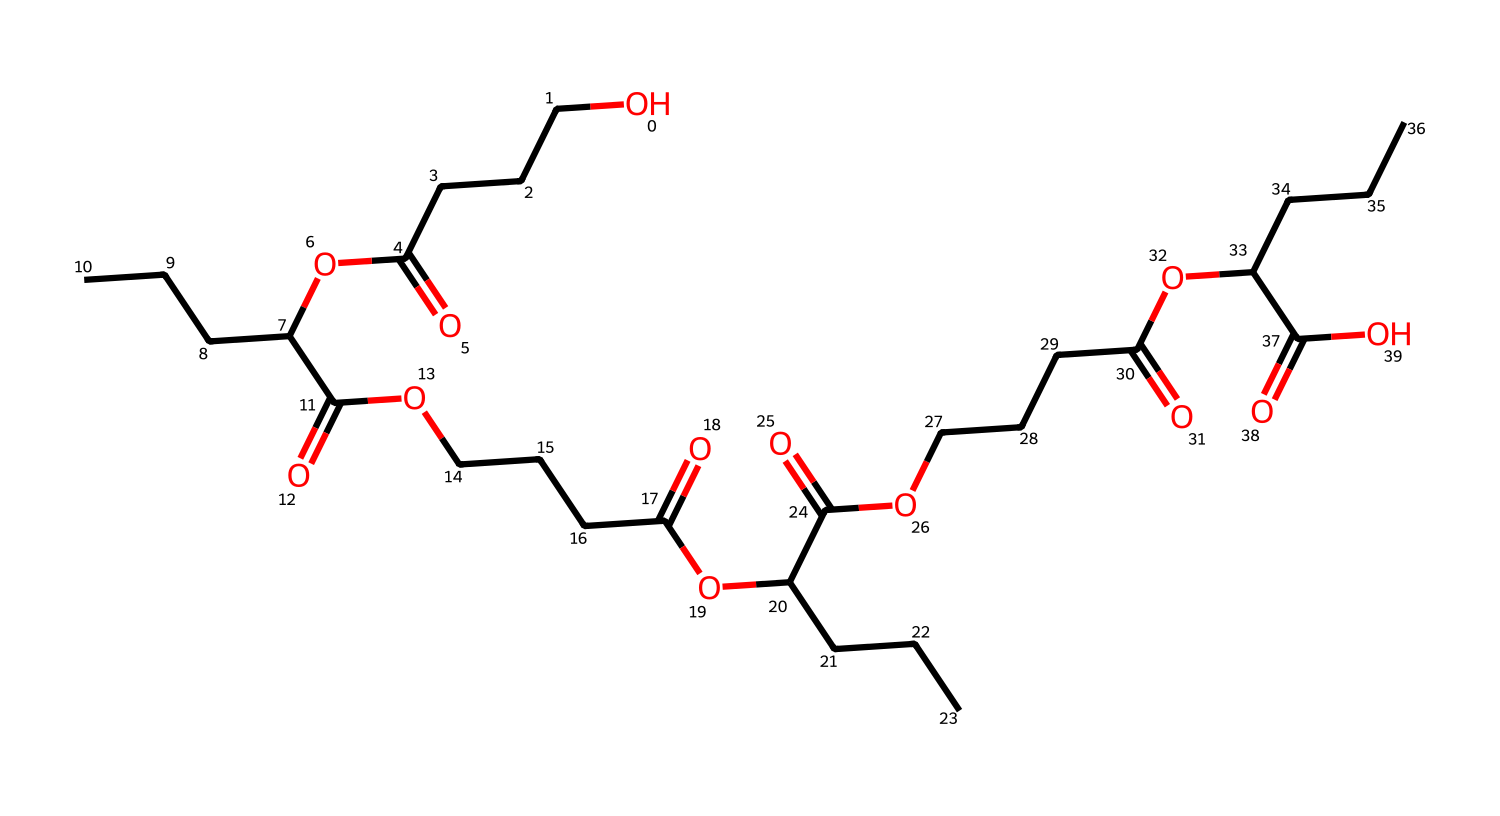how many carbon atoms are present in the structure? By counting the carbon atoms within the provided SMILES representation, I observe several "C" characters. Each "C" represents a carbon atom, and by meticulously tallying them throughout the representation, I find there are 24 carbon atoms in total.
Answer: 24 what type of functional groups are indicated in this chemical? In the SMILES, I notice multiple occurrences of "C(=O)", indicating carboxylic acids, and "O" preceding "C", which points to ester groups. This suggests the presence of both carboxylic acid and ester functional groups in the chemical structure.
Answer: carboxylic acid and ester how many ester groups are identified in this structure? The structure shows recurring patterns of "OC" connected to "C(=O)", which are characteristic of ester linkages. After inspecting the SMILES, it is clear that there are three distinct ester functional groups present in the molecule.
Answer: 3 what is the primary purpose of this chemical in commercial products? This chemical composition is specifically designed for creating biodegradable poop bags, which serve an environmental purpose by breaking down more effectively than traditional plastic counterparts in composting or landfills.
Answer: biodegradable poop bags does this compound have any polar characteristics? The presence of -COOH (carboxylic acid) groups and -O- (ether) linkages within the structure introduces polar characteristics due to the electronegativity of oxygen and the hydrogen bonding capabilities, which enhances solubility in water.
Answer: yes 